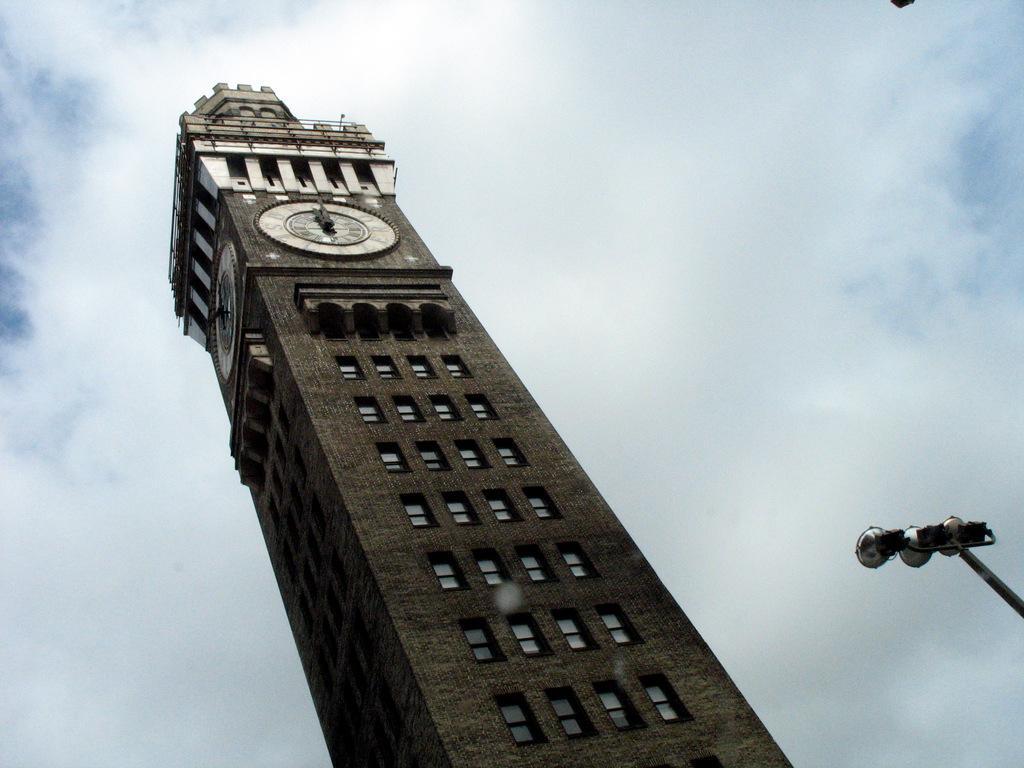How would you summarize this image in a sentence or two? On the right we can see a pole looking a like street light. In the center of the picture there is a building. At the top of the building there are clocks. In the background it is sky, sky is cloudy. 